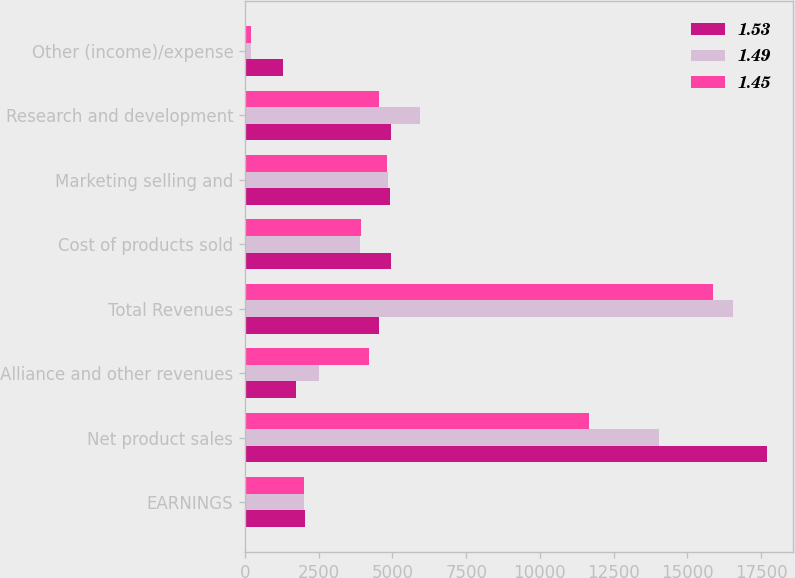Convert chart. <chart><loc_0><loc_0><loc_500><loc_500><stacked_bar_chart><ecel><fcel>EARNINGS<fcel>Net product sales<fcel>Alliance and other revenues<fcel>Total Revenues<fcel>Cost of products sold<fcel>Marketing selling and<fcel>Research and development<fcel>Other (income)/expense<nl><fcel>1.53<fcel>2016<fcel>17702<fcel>1725<fcel>4534<fcel>4946<fcel>4911<fcel>4940<fcel>1285<nl><fcel>1.49<fcel>2015<fcel>14045<fcel>2515<fcel>16560<fcel>3909<fcel>4841<fcel>5920<fcel>187<nl><fcel>1.45<fcel>2014<fcel>11660<fcel>4219<fcel>15879<fcel>3932<fcel>4822<fcel>4534<fcel>210<nl></chart> 